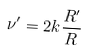<formula> <loc_0><loc_0><loc_500><loc_500>\nu ^ { \prime } = 2 k \frac { R ^ { \prime } } { R }</formula> 